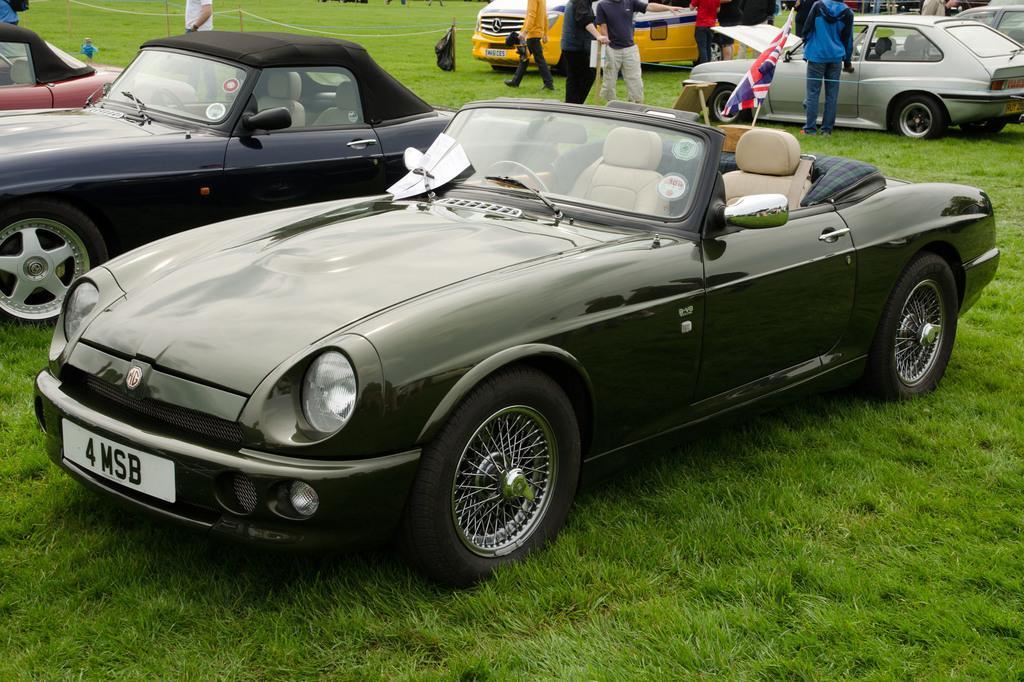Please provide a concise description of this image. This image is taken outdoors. At the bottom of the image there is a ground with grass on it. In the background a few cars are parked on the ground and a few people are standing on the ground and a man is walking on the ground. In the middle of the image three cars are parked on the ground and there is a flag. 